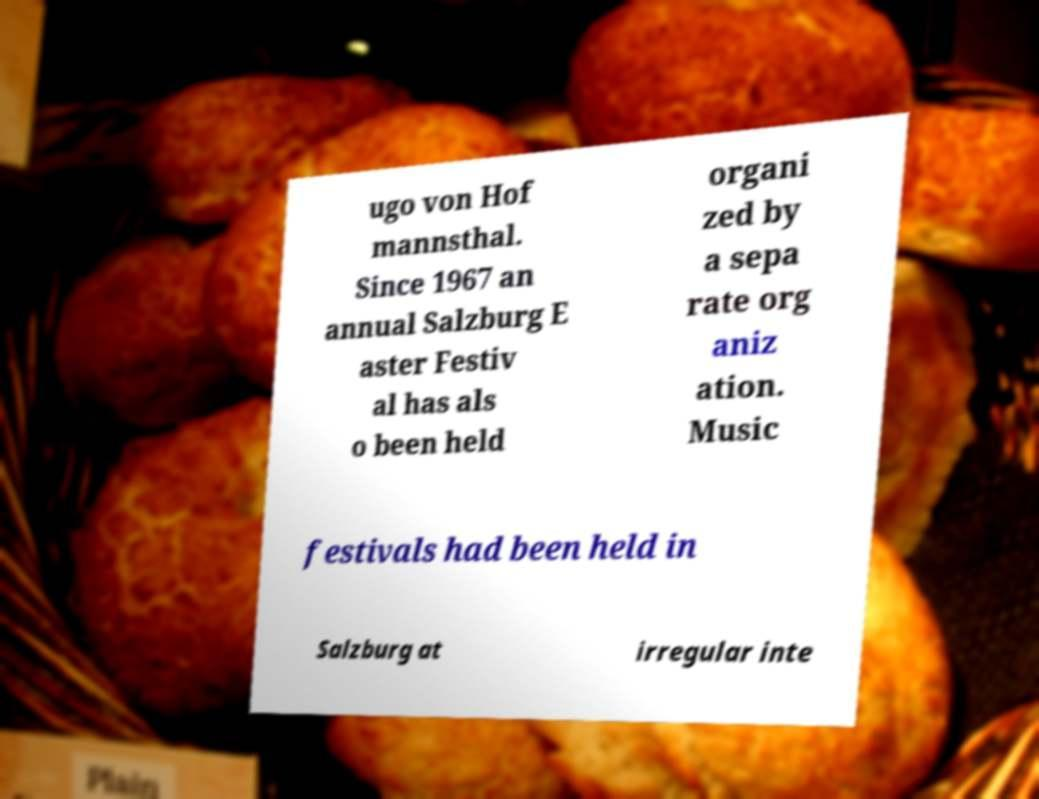For documentation purposes, I need the text within this image transcribed. Could you provide that? ugo von Hof mannsthal. Since 1967 an annual Salzburg E aster Festiv al has als o been held organi zed by a sepa rate org aniz ation. Music festivals had been held in Salzburg at irregular inte 